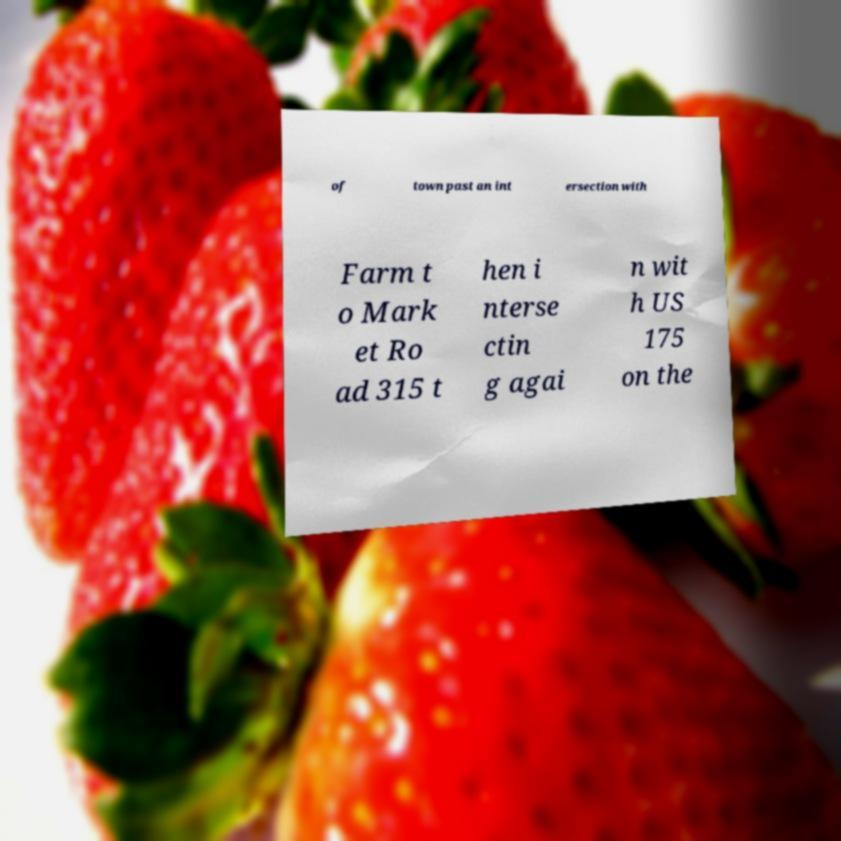I need the written content from this picture converted into text. Can you do that? of town past an int ersection with Farm t o Mark et Ro ad 315 t hen i nterse ctin g agai n wit h US 175 on the 